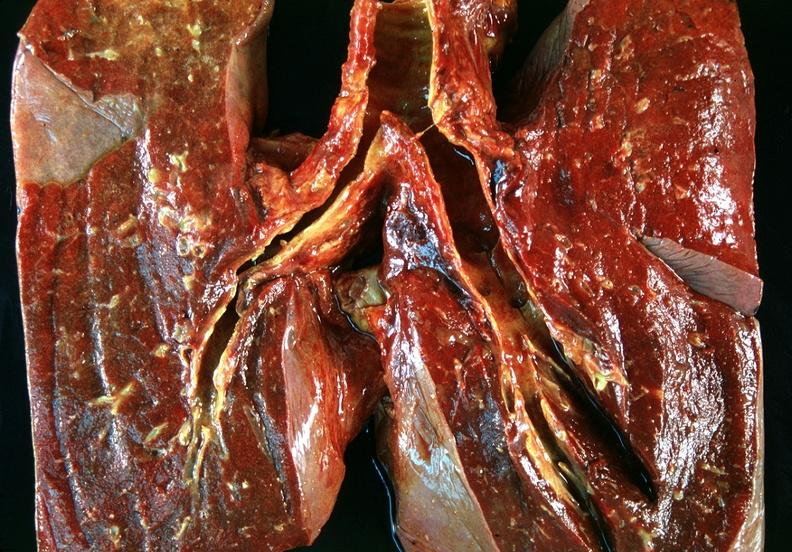what does this image show?
Answer the question using a single word or phrase. Lung 